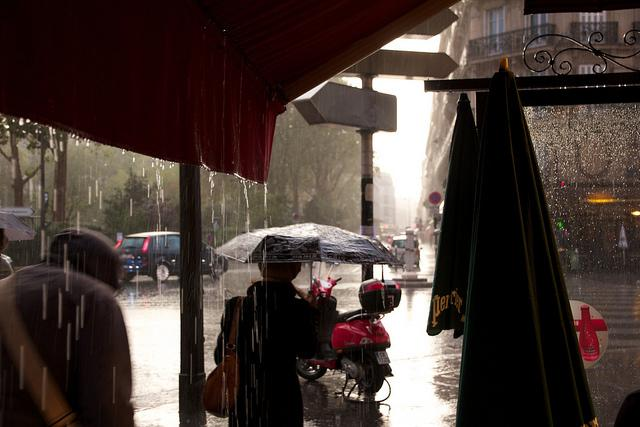Where does this water come from? Please explain your reasoning. sky. It is raining. 